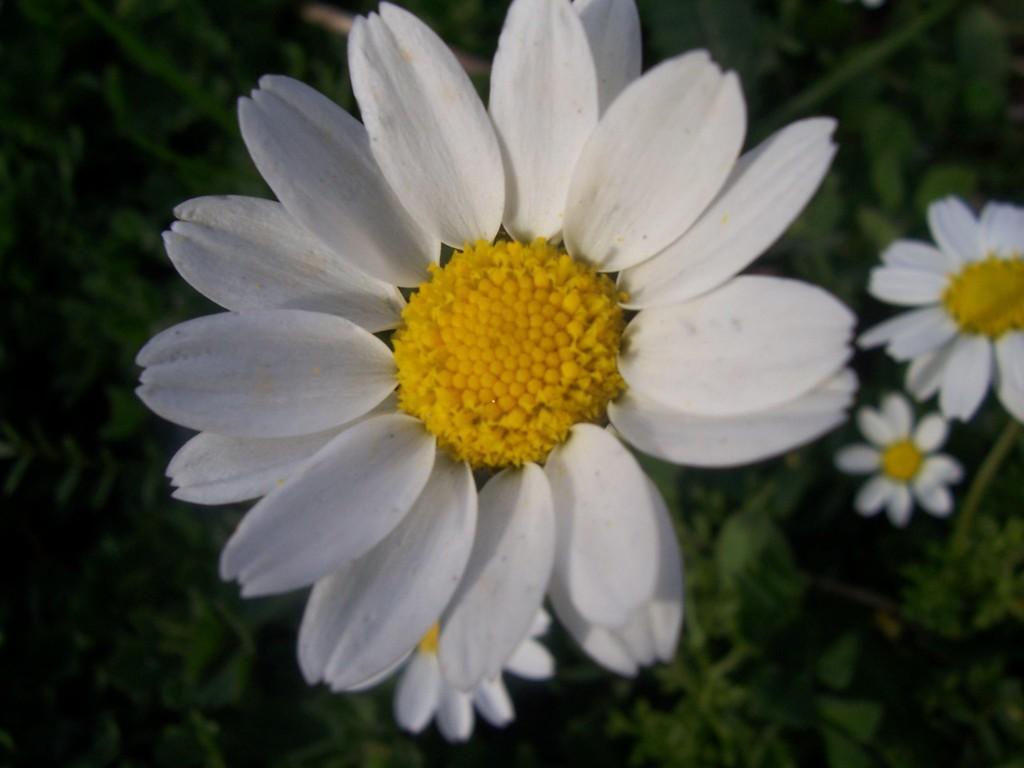Could you give a brief overview of what you see in this image? In this image we can see white flowers. Background it is in green color. 